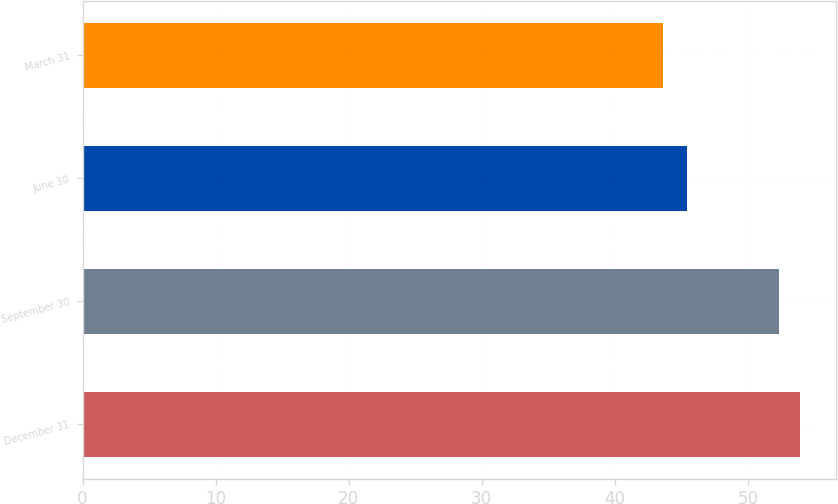<chart> <loc_0><loc_0><loc_500><loc_500><bar_chart><fcel>December 31<fcel>September 30<fcel>June 30<fcel>March 31<nl><fcel>53.91<fcel>52.36<fcel>45.4<fcel>43.6<nl></chart> 